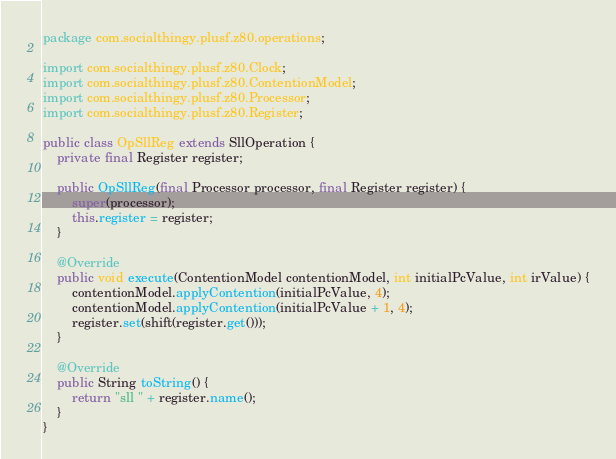<code> <loc_0><loc_0><loc_500><loc_500><_Java_>package com.socialthingy.plusf.z80.operations;

import com.socialthingy.plusf.z80.Clock;
import com.socialthingy.plusf.z80.ContentionModel;
import com.socialthingy.plusf.z80.Processor;
import com.socialthingy.plusf.z80.Register;

public class OpSllReg extends SllOperation {
    private final Register register;

    public OpSllReg(final Processor processor, final Register register) {
        super(processor);
        this.register = register;
    }

    @Override
    public void execute(ContentionModel contentionModel, int initialPcValue, int irValue) {
        contentionModel.applyContention(initialPcValue, 4);
        contentionModel.applyContention(initialPcValue + 1, 4);
        register.set(shift(register.get()));
    }

    @Override
    public String toString() {
        return "sll " + register.name();
    }
}
</code> 